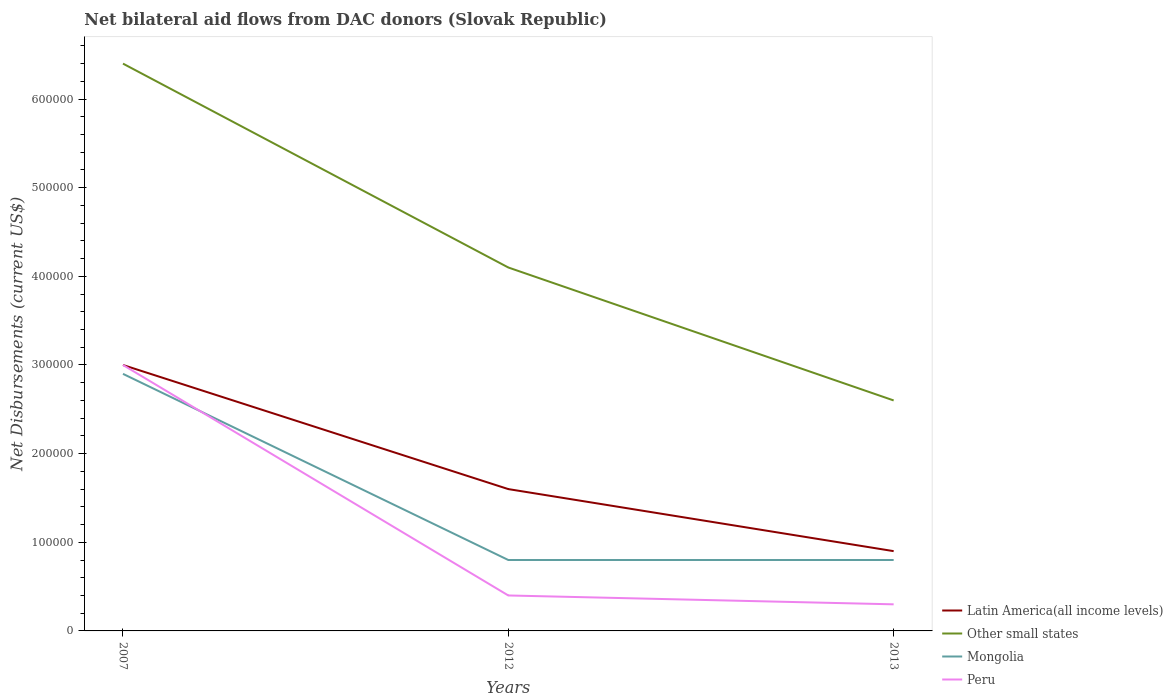How many different coloured lines are there?
Make the answer very short. 4. Does the line corresponding to Other small states intersect with the line corresponding to Latin America(all income levels)?
Give a very brief answer. No. What is the total net bilateral aid flows in Other small states in the graph?
Offer a terse response. 2.30e+05. What is the difference between the highest and the second highest net bilateral aid flows in Other small states?
Your response must be concise. 3.80e+05. Is the net bilateral aid flows in Other small states strictly greater than the net bilateral aid flows in Mongolia over the years?
Ensure brevity in your answer.  No. Does the graph contain any zero values?
Give a very brief answer. No. Where does the legend appear in the graph?
Your answer should be very brief. Bottom right. What is the title of the graph?
Your answer should be compact. Net bilateral aid flows from DAC donors (Slovak Republic). Does "Georgia" appear as one of the legend labels in the graph?
Your answer should be compact. No. What is the label or title of the X-axis?
Give a very brief answer. Years. What is the label or title of the Y-axis?
Offer a terse response. Net Disbursements (current US$). What is the Net Disbursements (current US$) in Other small states in 2007?
Make the answer very short. 6.40e+05. What is the Net Disbursements (current US$) in Mongolia in 2007?
Provide a succinct answer. 2.90e+05. What is the Net Disbursements (current US$) in Peru in 2007?
Your answer should be compact. 3.00e+05. What is the Net Disbursements (current US$) in Latin America(all income levels) in 2012?
Ensure brevity in your answer.  1.60e+05. What is the Net Disbursements (current US$) in Mongolia in 2012?
Provide a short and direct response. 8.00e+04. What is the Net Disbursements (current US$) in Peru in 2012?
Make the answer very short. 4.00e+04. What is the Net Disbursements (current US$) of Mongolia in 2013?
Give a very brief answer. 8.00e+04. What is the Net Disbursements (current US$) in Peru in 2013?
Your answer should be very brief. 3.00e+04. Across all years, what is the maximum Net Disbursements (current US$) in Other small states?
Keep it short and to the point. 6.40e+05. Across all years, what is the minimum Net Disbursements (current US$) in Peru?
Offer a very short reply. 3.00e+04. What is the total Net Disbursements (current US$) of Other small states in the graph?
Keep it short and to the point. 1.31e+06. What is the total Net Disbursements (current US$) in Mongolia in the graph?
Your answer should be very brief. 4.50e+05. What is the total Net Disbursements (current US$) of Peru in the graph?
Make the answer very short. 3.70e+05. What is the difference between the Net Disbursements (current US$) in Latin America(all income levels) in 2007 and that in 2012?
Ensure brevity in your answer.  1.40e+05. What is the difference between the Net Disbursements (current US$) of Other small states in 2007 and that in 2012?
Ensure brevity in your answer.  2.30e+05. What is the difference between the Net Disbursements (current US$) in Peru in 2007 and that in 2012?
Ensure brevity in your answer.  2.60e+05. What is the difference between the Net Disbursements (current US$) of Other small states in 2007 and that in 2013?
Your answer should be compact. 3.80e+05. What is the difference between the Net Disbursements (current US$) of Mongolia in 2007 and that in 2013?
Provide a succinct answer. 2.10e+05. What is the difference between the Net Disbursements (current US$) in Peru in 2007 and that in 2013?
Make the answer very short. 2.70e+05. What is the difference between the Net Disbursements (current US$) in Latin America(all income levels) in 2012 and that in 2013?
Provide a short and direct response. 7.00e+04. What is the difference between the Net Disbursements (current US$) in Other small states in 2012 and that in 2013?
Provide a succinct answer. 1.50e+05. What is the difference between the Net Disbursements (current US$) of Mongolia in 2012 and that in 2013?
Provide a short and direct response. 0. What is the difference between the Net Disbursements (current US$) of Other small states in 2007 and the Net Disbursements (current US$) of Mongolia in 2012?
Keep it short and to the point. 5.60e+05. What is the difference between the Net Disbursements (current US$) of Other small states in 2007 and the Net Disbursements (current US$) of Peru in 2012?
Your answer should be very brief. 6.00e+05. What is the difference between the Net Disbursements (current US$) of Other small states in 2007 and the Net Disbursements (current US$) of Mongolia in 2013?
Offer a terse response. 5.60e+05. What is the difference between the Net Disbursements (current US$) of Latin America(all income levels) in 2012 and the Net Disbursements (current US$) of Other small states in 2013?
Provide a short and direct response. -1.00e+05. What is the difference between the Net Disbursements (current US$) in Latin America(all income levels) in 2012 and the Net Disbursements (current US$) in Mongolia in 2013?
Your answer should be compact. 8.00e+04. What is the difference between the Net Disbursements (current US$) of Other small states in 2012 and the Net Disbursements (current US$) of Peru in 2013?
Your response must be concise. 3.80e+05. What is the average Net Disbursements (current US$) of Latin America(all income levels) per year?
Your answer should be very brief. 1.83e+05. What is the average Net Disbursements (current US$) of Other small states per year?
Provide a short and direct response. 4.37e+05. What is the average Net Disbursements (current US$) in Mongolia per year?
Your response must be concise. 1.50e+05. What is the average Net Disbursements (current US$) in Peru per year?
Offer a terse response. 1.23e+05. In the year 2007, what is the difference between the Net Disbursements (current US$) of Latin America(all income levels) and Net Disbursements (current US$) of Other small states?
Your answer should be very brief. -3.40e+05. In the year 2007, what is the difference between the Net Disbursements (current US$) of Latin America(all income levels) and Net Disbursements (current US$) of Mongolia?
Your answer should be very brief. 10000. In the year 2007, what is the difference between the Net Disbursements (current US$) of Other small states and Net Disbursements (current US$) of Peru?
Your response must be concise. 3.40e+05. In the year 2012, what is the difference between the Net Disbursements (current US$) in Latin America(all income levels) and Net Disbursements (current US$) in Mongolia?
Your answer should be compact. 8.00e+04. In the year 2012, what is the difference between the Net Disbursements (current US$) of Latin America(all income levels) and Net Disbursements (current US$) of Peru?
Offer a very short reply. 1.20e+05. In the year 2012, what is the difference between the Net Disbursements (current US$) of Other small states and Net Disbursements (current US$) of Mongolia?
Ensure brevity in your answer.  3.30e+05. In the year 2012, what is the difference between the Net Disbursements (current US$) of Other small states and Net Disbursements (current US$) of Peru?
Provide a short and direct response. 3.70e+05. In the year 2013, what is the difference between the Net Disbursements (current US$) of Latin America(all income levels) and Net Disbursements (current US$) of Mongolia?
Keep it short and to the point. 10000. In the year 2013, what is the difference between the Net Disbursements (current US$) in Other small states and Net Disbursements (current US$) in Mongolia?
Provide a short and direct response. 1.80e+05. In the year 2013, what is the difference between the Net Disbursements (current US$) in Mongolia and Net Disbursements (current US$) in Peru?
Make the answer very short. 5.00e+04. What is the ratio of the Net Disbursements (current US$) in Latin America(all income levels) in 2007 to that in 2012?
Keep it short and to the point. 1.88. What is the ratio of the Net Disbursements (current US$) in Other small states in 2007 to that in 2012?
Your response must be concise. 1.56. What is the ratio of the Net Disbursements (current US$) in Mongolia in 2007 to that in 2012?
Ensure brevity in your answer.  3.62. What is the ratio of the Net Disbursements (current US$) in Other small states in 2007 to that in 2013?
Your answer should be very brief. 2.46. What is the ratio of the Net Disbursements (current US$) of Mongolia in 2007 to that in 2013?
Your answer should be compact. 3.62. What is the ratio of the Net Disbursements (current US$) in Latin America(all income levels) in 2012 to that in 2013?
Offer a very short reply. 1.78. What is the ratio of the Net Disbursements (current US$) in Other small states in 2012 to that in 2013?
Keep it short and to the point. 1.58. What is the ratio of the Net Disbursements (current US$) in Peru in 2012 to that in 2013?
Keep it short and to the point. 1.33. What is the difference between the highest and the second highest Net Disbursements (current US$) of Other small states?
Keep it short and to the point. 2.30e+05. What is the difference between the highest and the second highest Net Disbursements (current US$) of Peru?
Your answer should be very brief. 2.60e+05. What is the difference between the highest and the lowest Net Disbursements (current US$) in Other small states?
Ensure brevity in your answer.  3.80e+05. What is the difference between the highest and the lowest Net Disbursements (current US$) in Mongolia?
Make the answer very short. 2.10e+05. What is the difference between the highest and the lowest Net Disbursements (current US$) in Peru?
Give a very brief answer. 2.70e+05. 